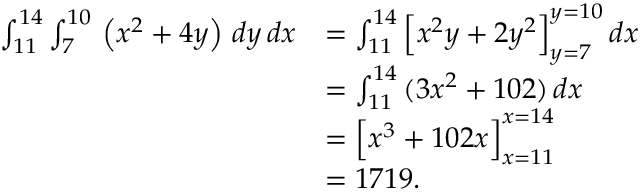<formula> <loc_0><loc_0><loc_500><loc_500>{ \begin{array} { r l } { \int _ { 1 1 } ^ { 1 4 } \int _ { 7 } ^ { 1 0 } \, \left ( x ^ { 2 } + 4 y \right ) \, d y \, d x } & { = \int _ { 1 1 } ^ { 1 4 } { \left [ } x ^ { 2 } y + 2 y ^ { 2 } { \right ] } _ { y = 7 } ^ { y = 1 0 } \, d x } \\ & { = \int _ { 1 1 } ^ { 1 4 } \, ( 3 x ^ { 2 } + 1 0 2 ) \, d x } \\ & { = { \left [ } x ^ { 3 } + 1 0 2 x { \right ] } _ { x = 1 1 } ^ { x = 1 4 } } \\ & { = 1 7 1 9 . } \end{array} }</formula> 